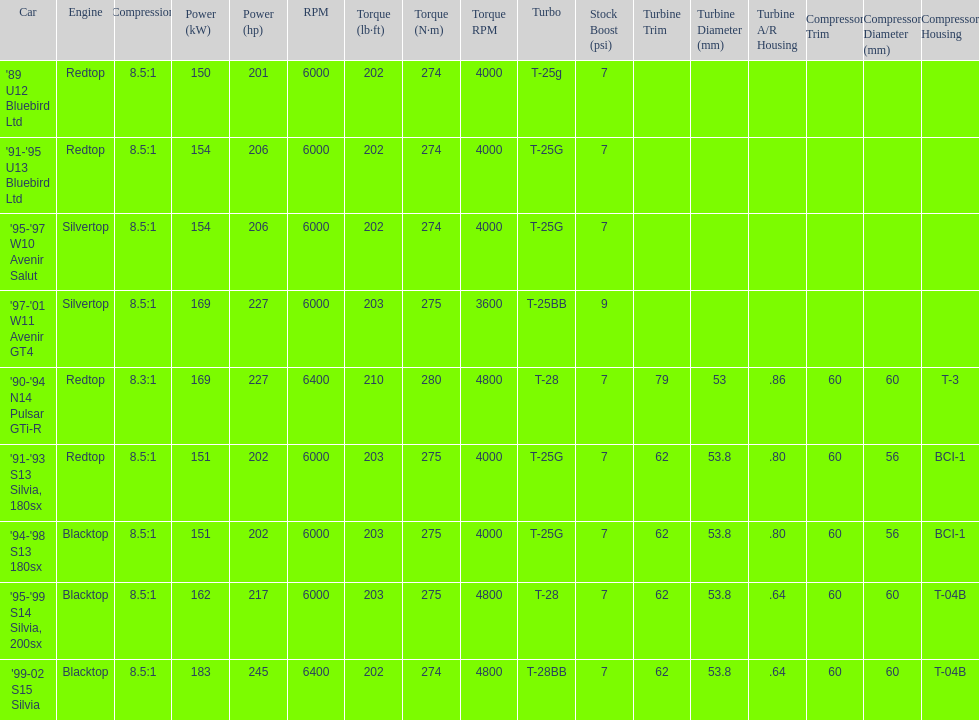Which car is the only one with more than 230 hp? '99-02 S15 Silvia. 